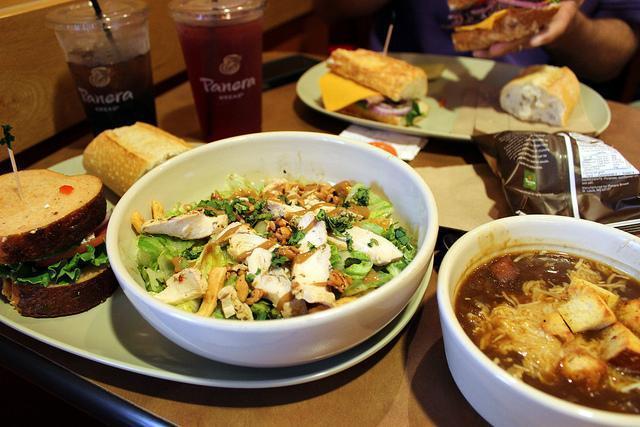How many cups can be seen?
Give a very brief answer. 2. How many bowls can you see?
Give a very brief answer. 2. How many sandwiches are in the photo?
Give a very brief answer. 3. 